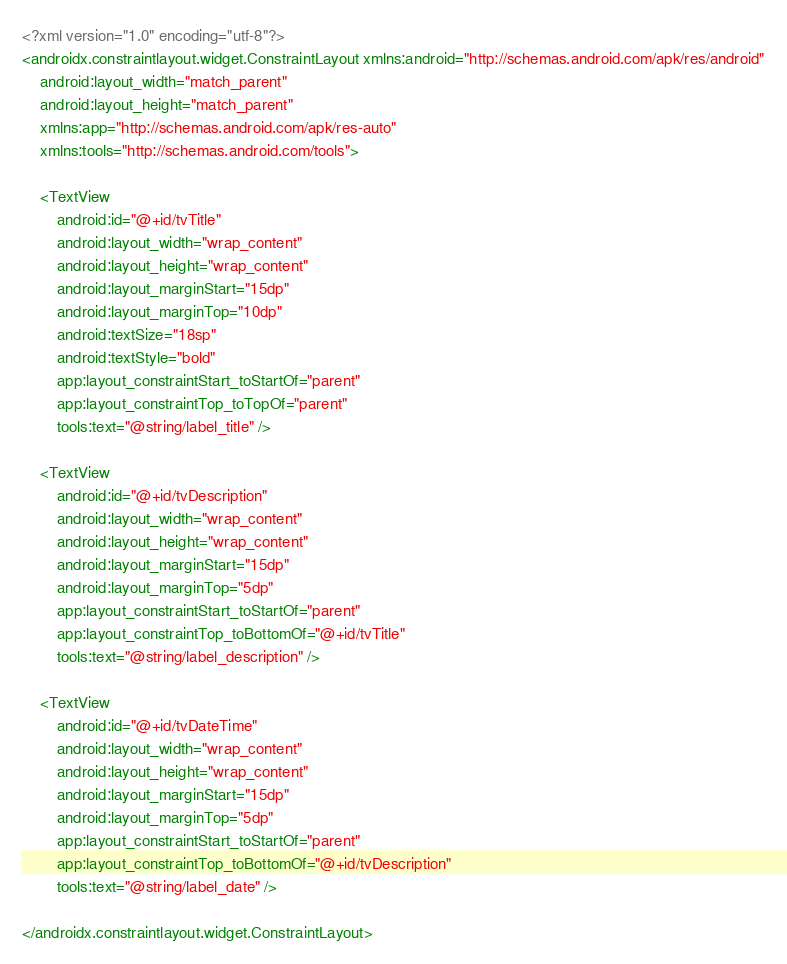Convert code to text. <code><loc_0><loc_0><loc_500><loc_500><_XML_><?xml version="1.0" encoding="utf-8"?>
<androidx.constraintlayout.widget.ConstraintLayout xmlns:android="http://schemas.android.com/apk/res/android"
    android:layout_width="match_parent"
    android:layout_height="match_parent"
    xmlns:app="http://schemas.android.com/apk/res-auto"
    xmlns:tools="http://schemas.android.com/tools">

    <TextView
        android:id="@+id/tvTitle"
        android:layout_width="wrap_content"
        android:layout_height="wrap_content"
        android:layout_marginStart="15dp"
        android:layout_marginTop="10dp"
        android:textSize="18sp"
        android:textStyle="bold"
        app:layout_constraintStart_toStartOf="parent"
        app:layout_constraintTop_toTopOf="parent"
        tools:text="@string/label_title" />

    <TextView
        android:id="@+id/tvDescription"
        android:layout_width="wrap_content"
        android:layout_height="wrap_content"
        android:layout_marginStart="15dp"
        android:layout_marginTop="5dp"
        app:layout_constraintStart_toStartOf="parent"
        app:layout_constraintTop_toBottomOf="@+id/tvTitle"
        tools:text="@string/label_description" />

    <TextView
        android:id="@+id/tvDateTime"
        android:layout_width="wrap_content"
        android:layout_height="wrap_content"
        android:layout_marginStart="15dp"
        android:layout_marginTop="5dp"
        app:layout_constraintStart_toStartOf="parent"
        app:layout_constraintTop_toBottomOf="@+id/tvDescription"
        tools:text="@string/label_date" />

</androidx.constraintlayout.widget.ConstraintLayout></code> 